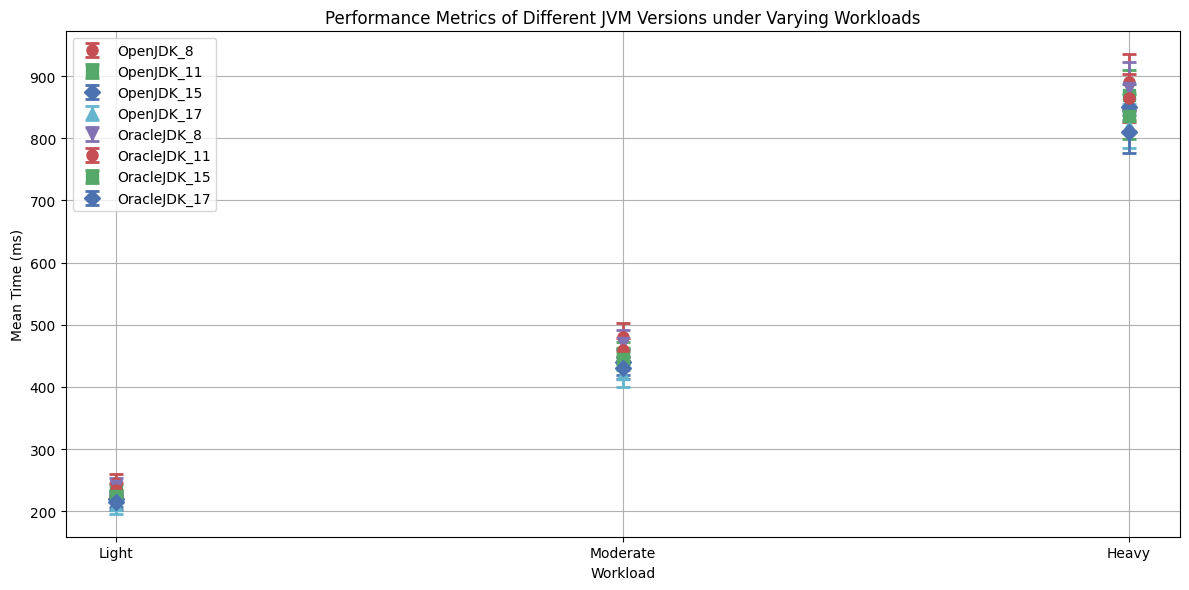Which JVM version has the lowest mean time under heavy workload? Look at the heavy workload group and compare mean times for each JVM version. OpenJDK_17 has the lowest mean time at 820 ms.
Answer: OpenJDK_17 What is the difference in mean time between OpenJDK_8 and OracleJDK_8 under moderate workload? Refer to the moderate workload group and subtract the mean time of OpenJDK_8 (480 ms) from OracleJDK_8 (470 ms). The difference is 480 - 470 = 10 ms.
Answer: 10 ms Which JVM version shows the greatest variability in performance under light workload? Examine the standard deviations for the light workload; OpenJDK_8 has the highest standard deviation at 15 ms.
Answer: OpenJDK_8 Across all workloads, what is the standard deviation range for OracleJDK_17? Look at the minimum and maximum standard deviation values for OracleJDK_17: light (13 ms), moderate (18 ms), and heavy (34 ms). The range is 34 - 13 = 21 ms.
Answer: 21 ms How does the performance of OpenJDK_11 under heavy workload compare to the performance of OracleJDK_11 under light workload? Compare the mean times: OpenJDK_11 under heavy workload is 870 ms, OracleJDK_11 under light workload is 235 ms. OpenJDK_11 under heavy workload takes 870 - 235 = 635 ms longer.
Answer: 635 ms longer 